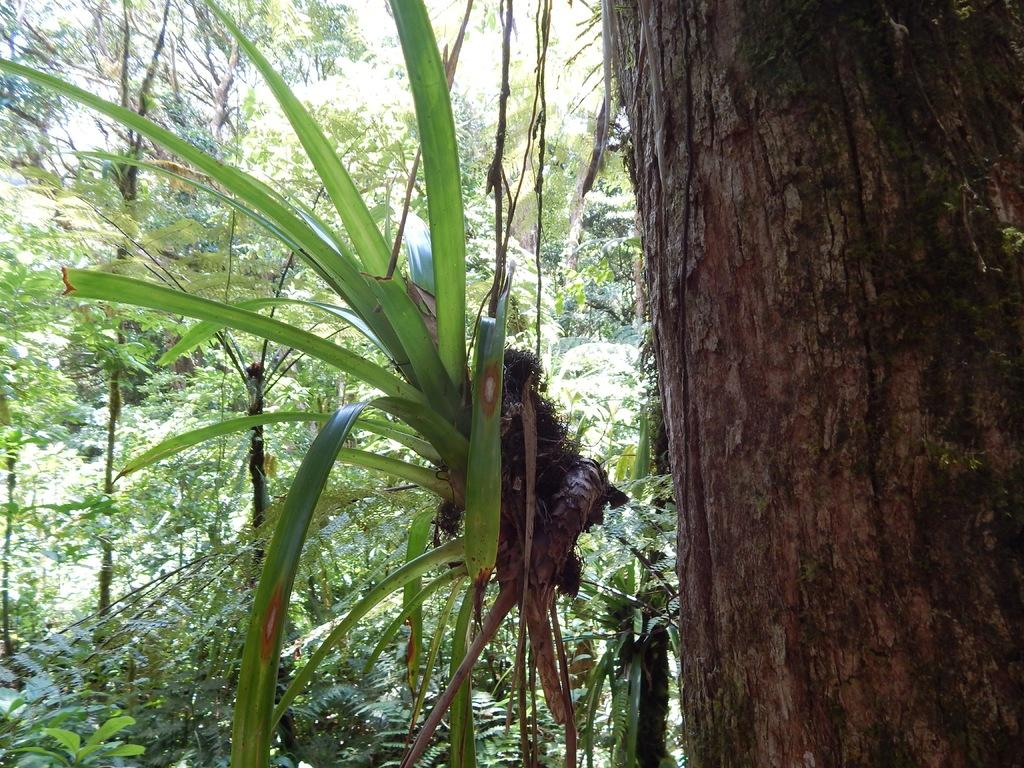What type of vegetation can be seen in the image? There are trees in the image. Can you describe a specific part of a tree that is visible in the image? There is a tree trunk in the image. What type of gold object is hanging from the tree trunk in the image? There is no gold object present in the image; it only features trees and a tree trunk. 